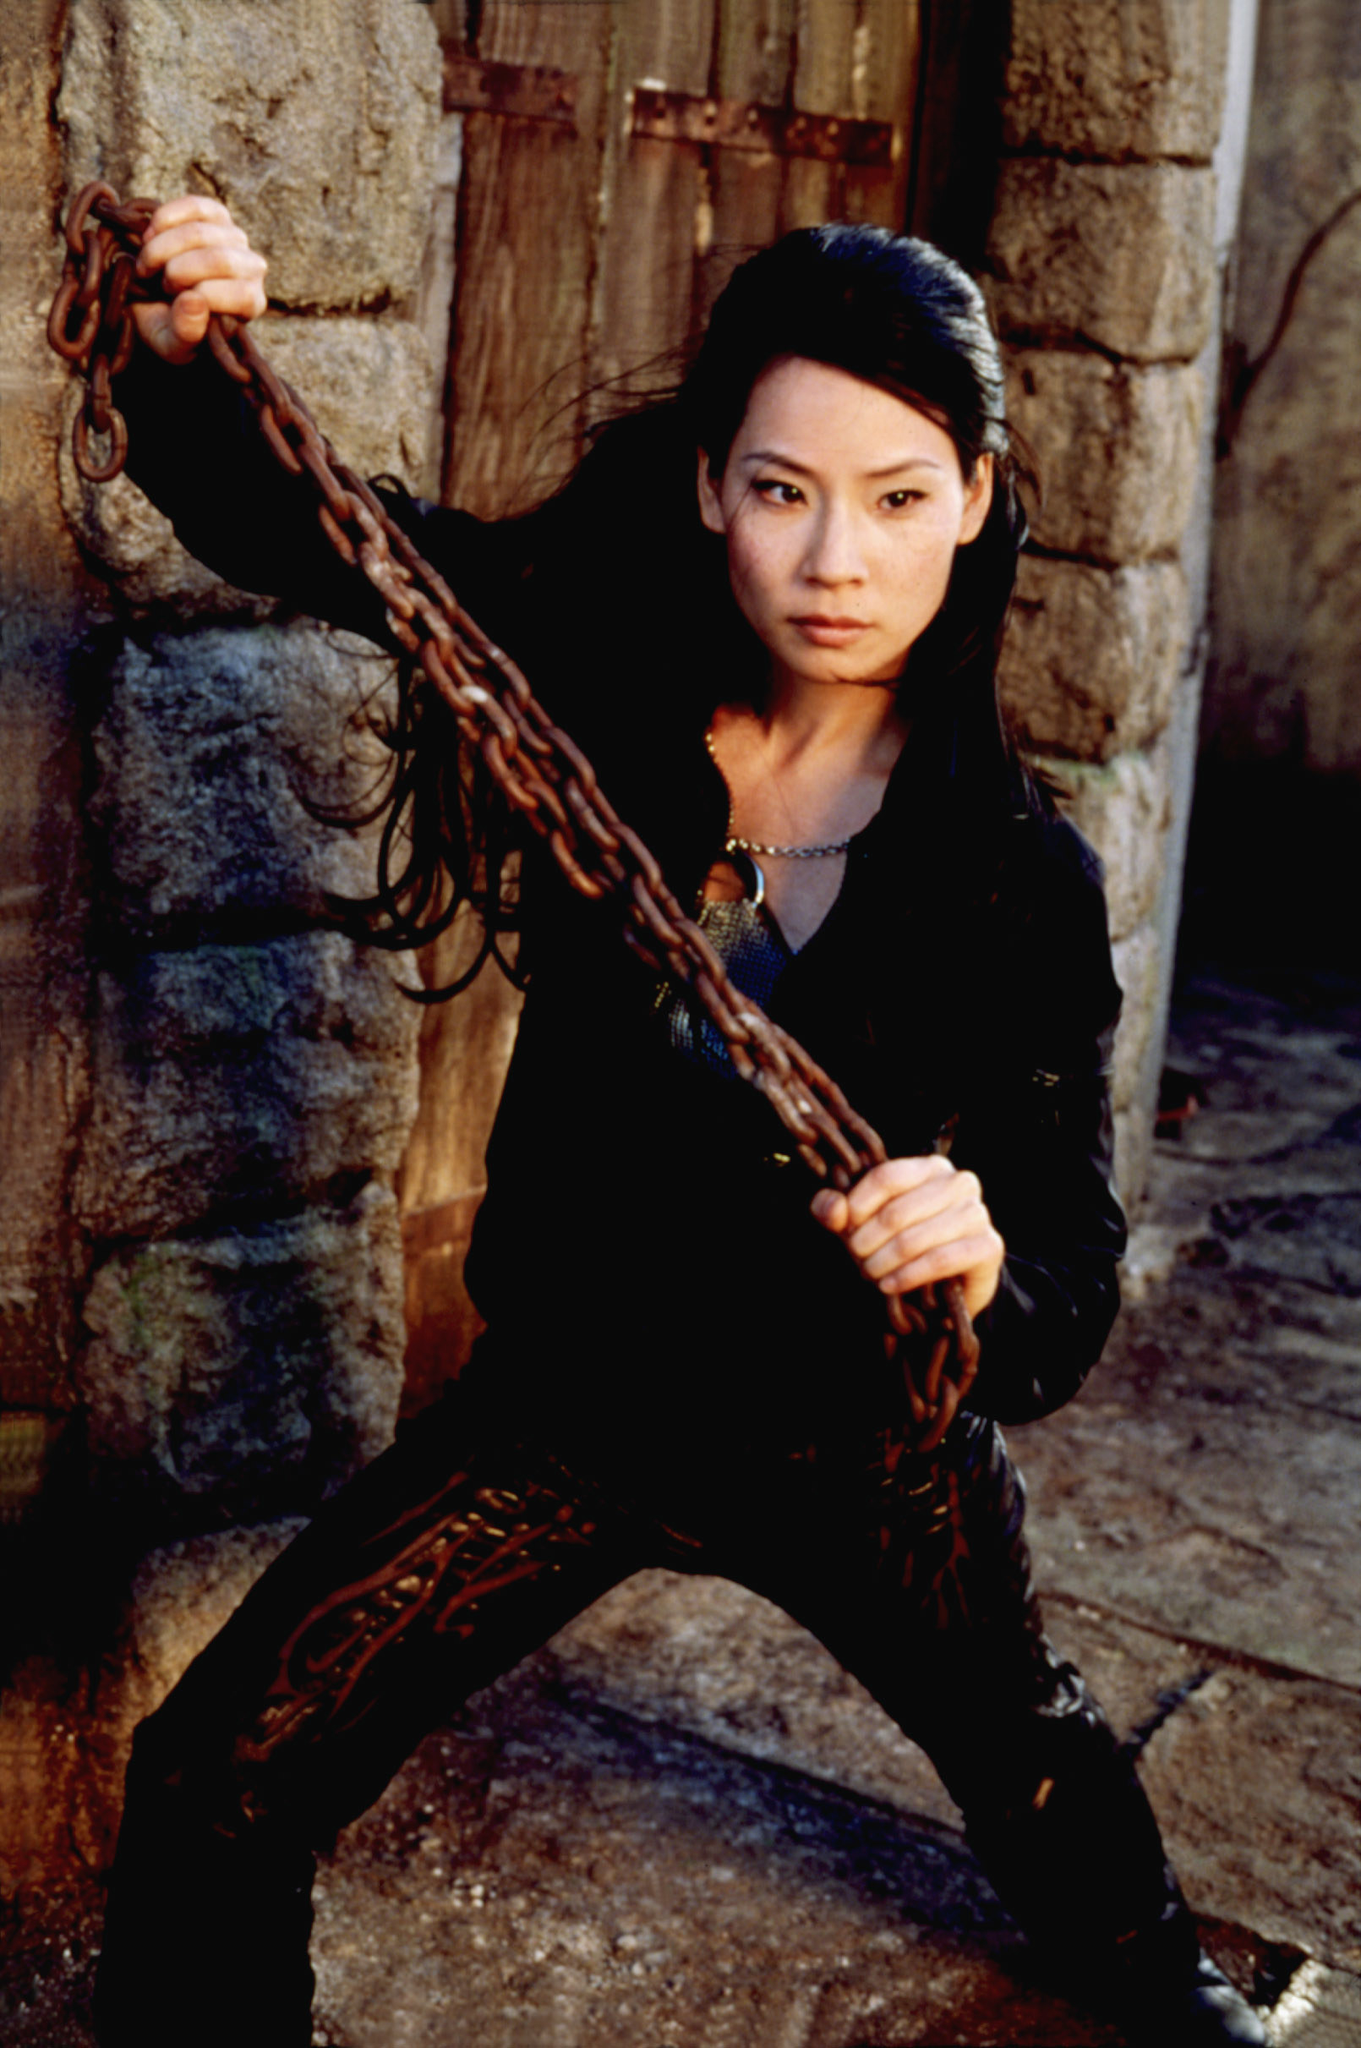What kind of emotions does the character convey through her expression and body language? The character's expression and body language convey a mix of determination, readiness, and confidence. Her focused gaze suggests she is thoroughly prepared for whatever challenge lies ahead. The grip on the chain indicates strength and control, while her relaxed hip suggests a sense of calm under pressure. Overall, she radiates an aura of resilience and competence. If this character were to speak a line of dialogue at this moment, what might she say? 'I've been waiting for this moment. Let the battle begin.' This line would fit well with her poised and ready stance, emphasizing her anticipation and readiness for the confrontation ahead. Can you craft a vivid and imaginative backstory for this character? Certainly! This character, known as Alexantra, hails from a lineage of elite warrior guardians who have protected their realm for generations. Trained from a young age, she excelled in combat, strategy, and the mystic arts. The chain in her hand is a legendary artifact, imbued with the power to summon elemental forces. Once a revered protector of a sacred relic, Alexantra now faces a new threat seeking to resurrect an ancient evil. With her homeland at stake, she stands resolute, ready to confront any adversary that dares to challenge her. Her journey is one of bravery, sacrifice, and an unyielding commitment to her duty. Imagine a realistic scenario where this character finds herself in a modern urban environment. What would she be doing? In a modern urban environment, Alexantra might be working as a covert operative for a secretive agency dedicated to combating supernatural threats. Her skills in hand-to-hand combat and strategic thinking would make her an invaluable asset. She could be seen navigating shadowy back alleys, gathering intelligence, and neutralizing threats before they escalate. Despite the change in setting, her determination and focus would remain unwavering, adapting her ancient training to the challenges of a contemporary world. Now, imagine a whimsical scenario where the character is transported into a fanciful world. What kind of adventures would she embark on? Transported into a whimsical world full of enchanted forests, talking animals, and magical realms, Alexantra would embark on a quest to restore balance and harmony. She might team up with a group of quirky, lovable companions, including a wise-cracking fairy, a courageous talking fox, and a mysterious sorcerer. Together, they would face whimsical challenges like outwitting trickster spirits, solving ancient puzzles guarded by mythical creatures, and navigating a labyrinth of shifting landscapes. Along the way, Alexantra would discover the power of friendship and the magic that lies within her heart, strengthening her resolve to protect all that is good and just. 